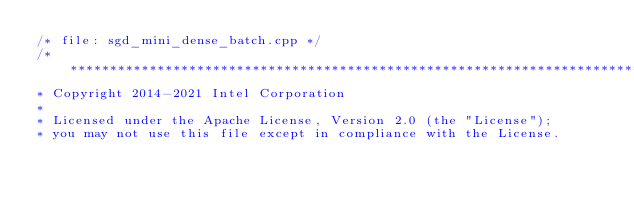<code> <loc_0><loc_0><loc_500><loc_500><_C++_>/* file: sgd_mini_dense_batch.cpp */
/*******************************************************************************
* Copyright 2014-2021 Intel Corporation
*
* Licensed under the Apache License, Version 2.0 (the "License");
* you may not use this file except in compliance with the License.</code> 